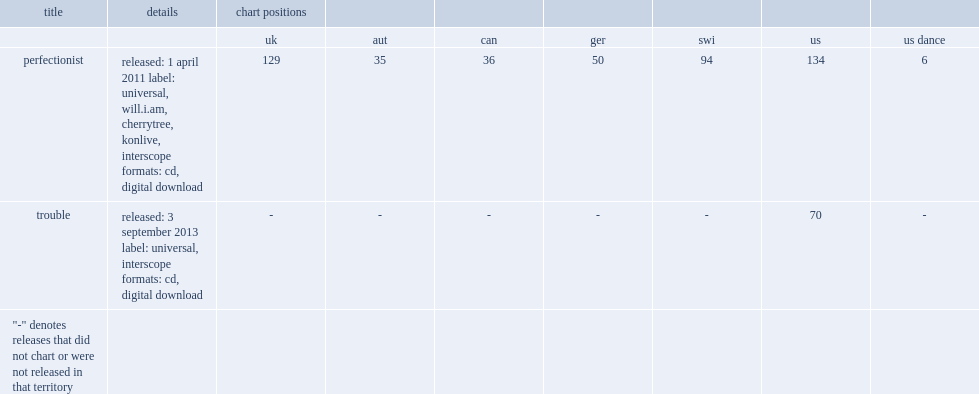What was the chart position on the us of perfectionist? 134.0. 